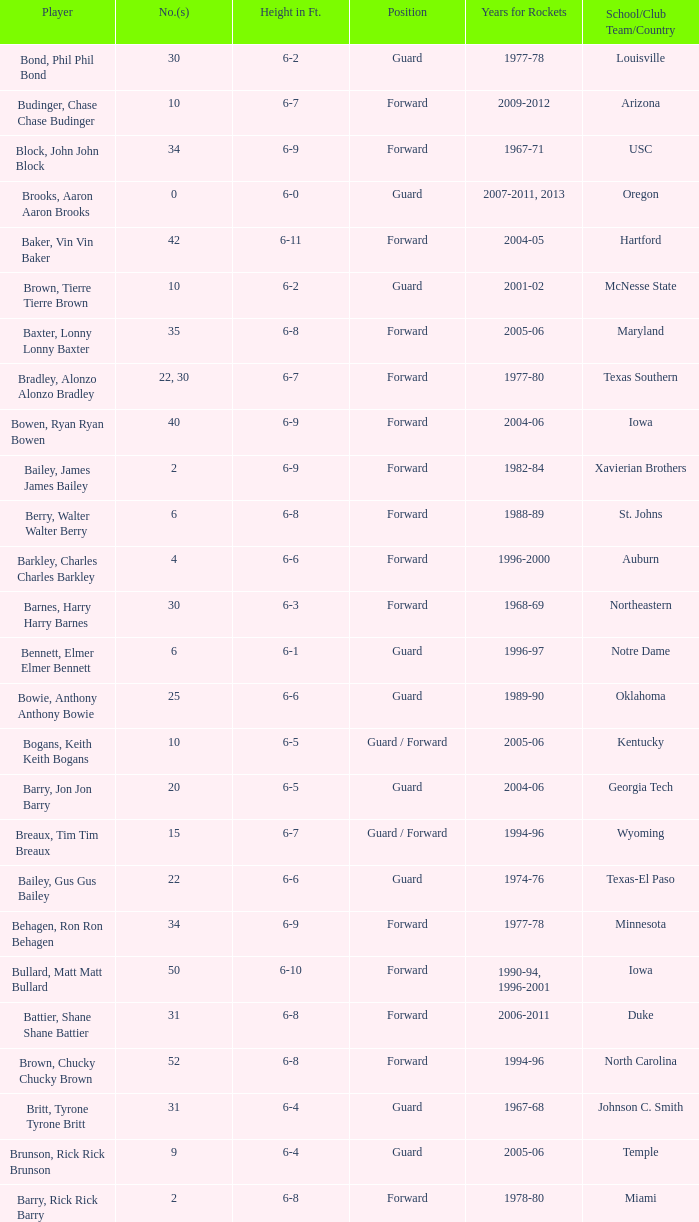What is the height of the player who attended Hartford? 6-11. 